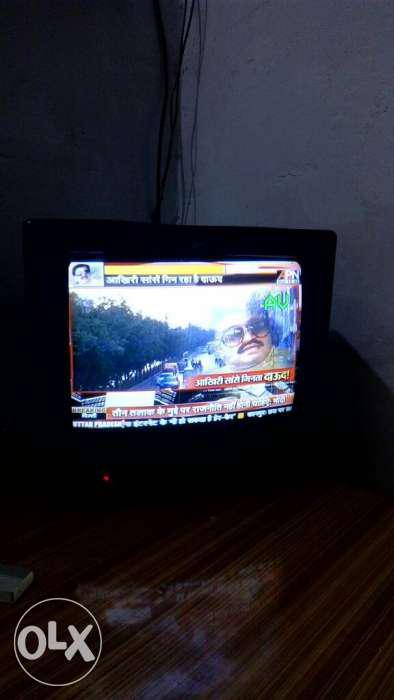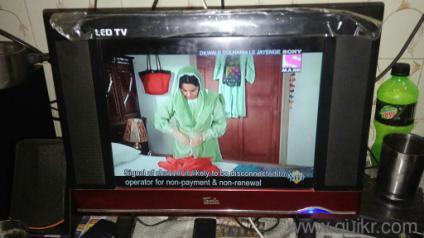The first image is the image on the left, the second image is the image on the right. For the images displayed, is the sentence "There is a single television that is off in the image on the right." factually correct? Answer yes or no. No. The first image is the image on the left, the second image is the image on the right. For the images displayed, is the sentence "An image shows a group of screened appliances stacked on top of one another." factually correct? Answer yes or no. No. 